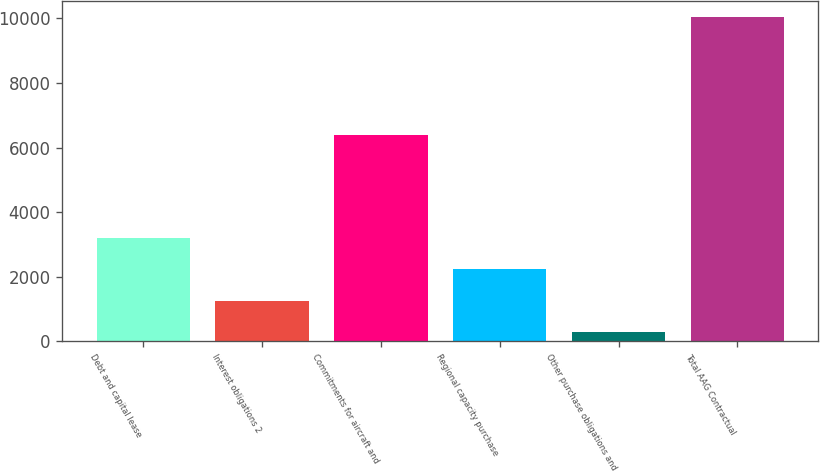Convert chart. <chart><loc_0><loc_0><loc_500><loc_500><bar_chart><fcel>Debt and capital lease<fcel>Interest obligations 2<fcel>Commitments for aircraft and<fcel>Regional capacity purchase<fcel>Other purchase obligations and<fcel>Total AAG Contractual<nl><fcel>3202<fcel>1250<fcel>6387<fcel>2226<fcel>274<fcel>10034<nl></chart> 